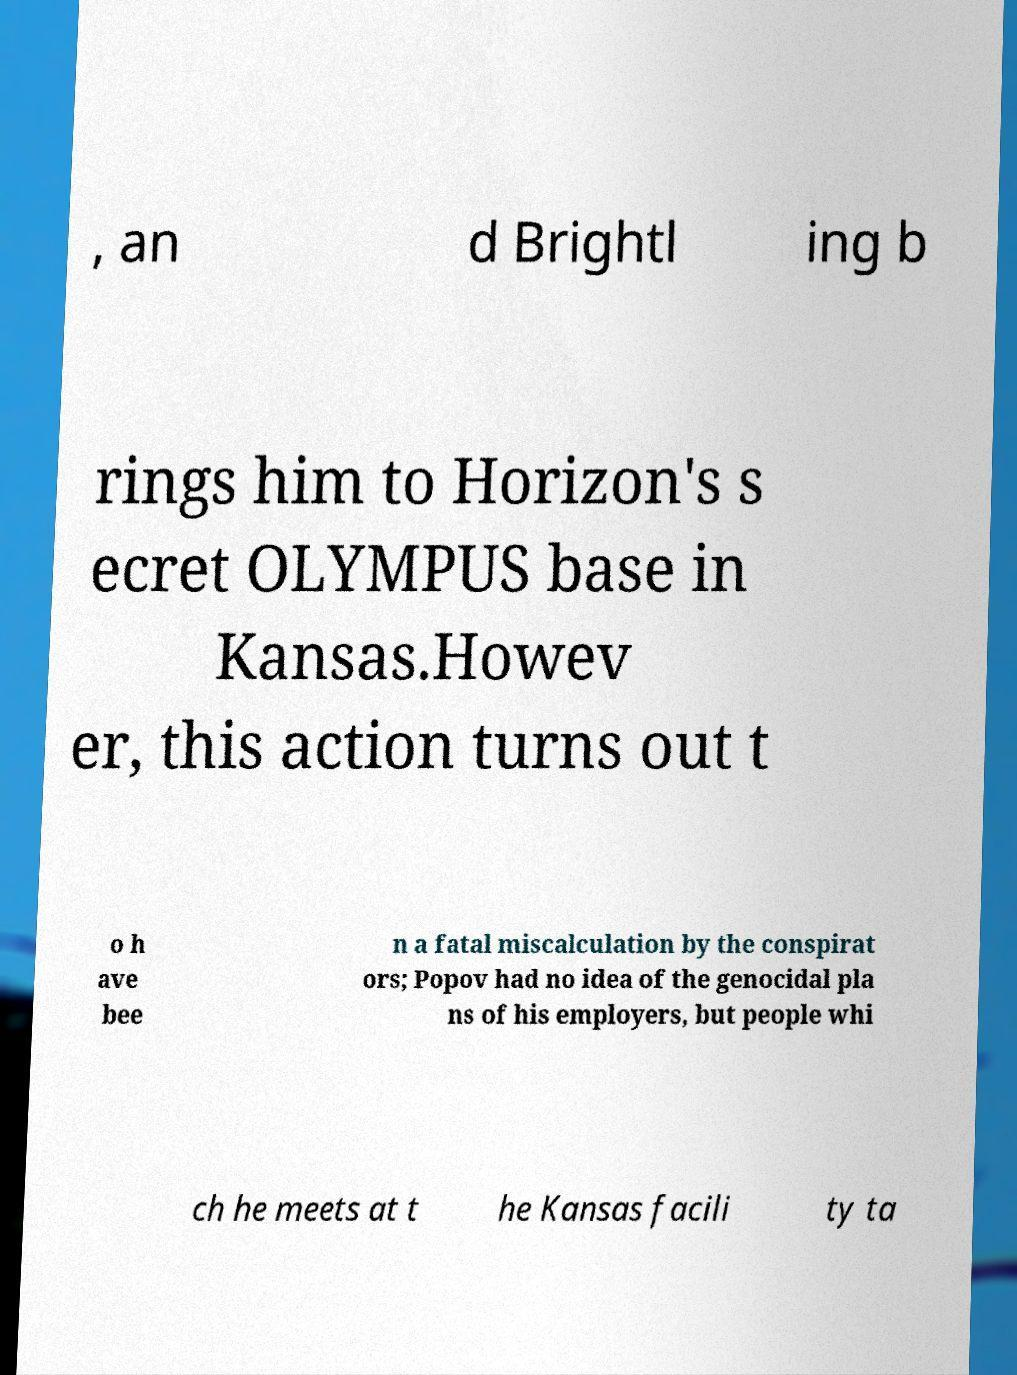I need the written content from this picture converted into text. Can you do that? , an d Brightl ing b rings him to Horizon's s ecret OLYMPUS base in Kansas.Howev er, this action turns out t o h ave bee n a fatal miscalculation by the conspirat ors; Popov had no idea of the genocidal pla ns of his employers, but people whi ch he meets at t he Kansas facili ty ta 